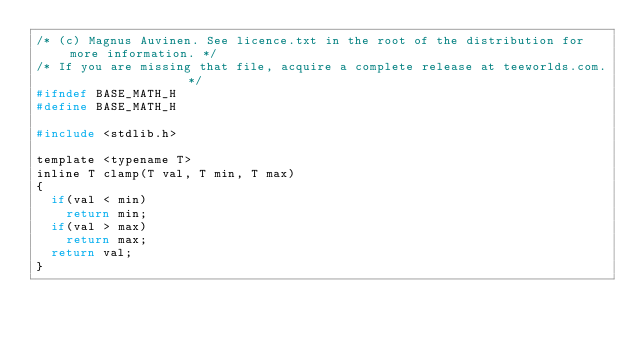<code> <loc_0><loc_0><loc_500><loc_500><_C_>/* (c) Magnus Auvinen. See licence.txt in the root of the distribution for more information. */
/* If you are missing that file, acquire a complete release at teeworlds.com.                */
#ifndef BASE_MATH_H
#define BASE_MATH_H

#include <stdlib.h>

template <typename T>
inline T clamp(T val, T min, T max)
{
	if(val < min)
		return min;
	if(val > max)
		return max;
	return val;
}
</code> 